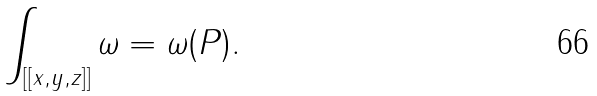<formula> <loc_0><loc_0><loc_500><loc_500>\int _ { [ [ x , y , z ] ] } \omega = \omega ( P ) .</formula> 